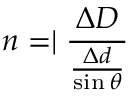Convert formula to latex. <formula><loc_0><loc_0><loc_500><loc_500>n = | \frac { \Delta D } { \frac { \Delta d } { \sin \theta } }</formula> 